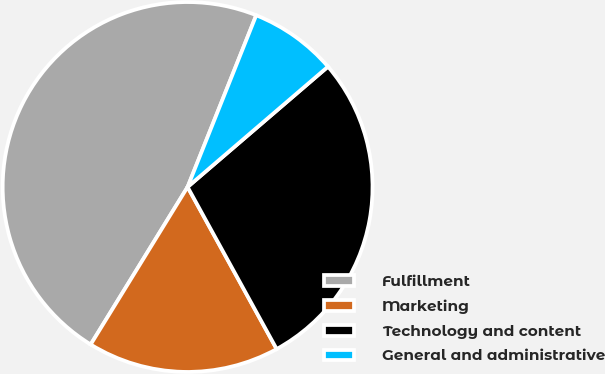Convert chart to OTSL. <chart><loc_0><loc_0><loc_500><loc_500><pie_chart><fcel>Fulfillment<fcel>Marketing<fcel>Technology and content<fcel>General and administrative<nl><fcel>47.27%<fcel>16.78%<fcel>28.28%<fcel>7.67%<nl></chart> 